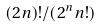Convert formula to latex. <formula><loc_0><loc_0><loc_500><loc_500>( 2 n ) ! / ( 2 ^ { n } n ! )</formula> 